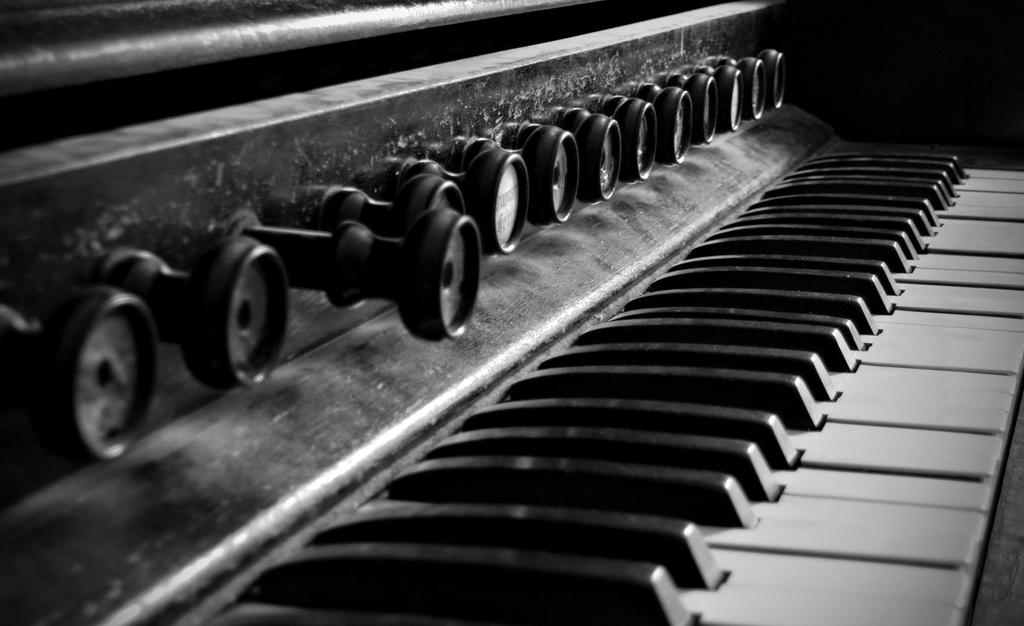What type of object is the main subject in the image? There is a musical instrument in the image. Can you see any caves or apples in the image? No, there are no caves or apples present in the image. 